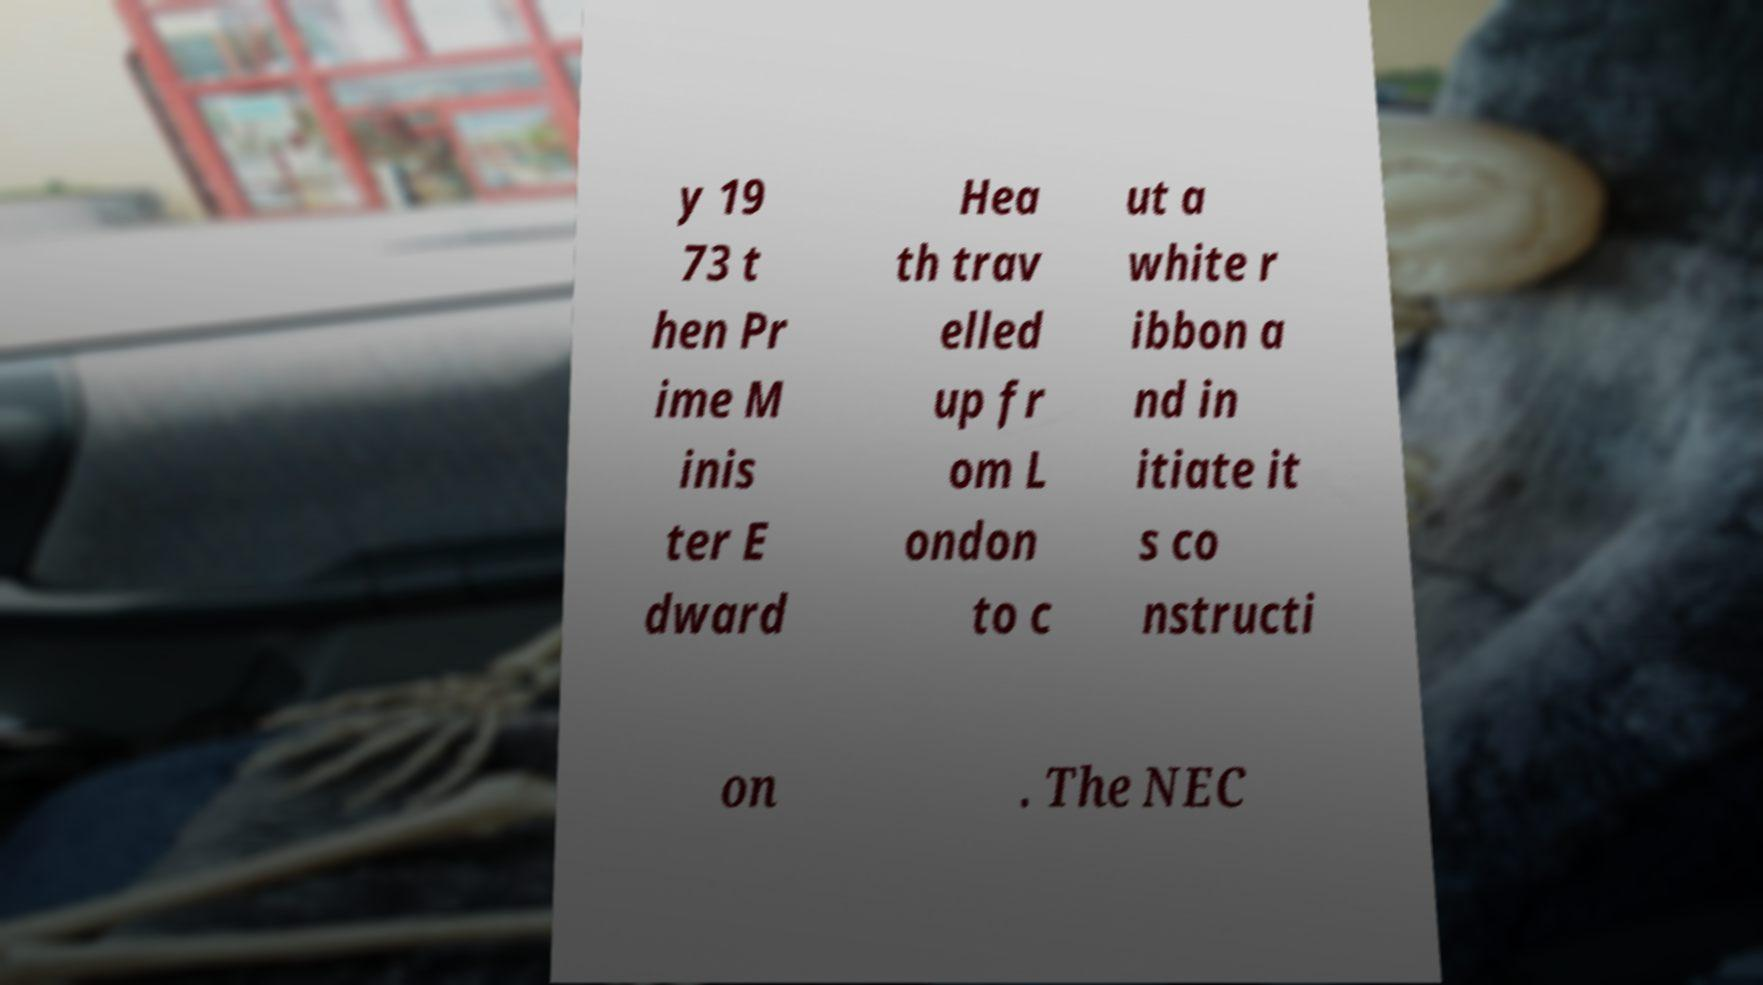For documentation purposes, I need the text within this image transcribed. Could you provide that? y 19 73 t hen Pr ime M inis ter E dward Hea th trav elled up fr om L ondon to c ut a white r ibbon a nd in itiate it s co nstructi on . The NEC 